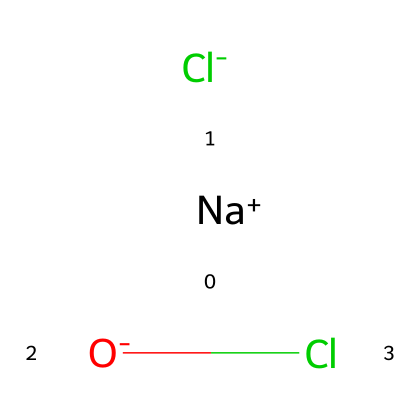What is the chemical name of this compound? The SMILES representation shows the presence of sodium (Na+), chloride (Cl-), and hypochlorite (O-) ions, which collectively represent sodium hypochlorite, commonly known as bleach.
Answer: sodium hypochlorite How many chlorine atoms are present in this chemical? Analyzing the SMILES structure, there are two chlorine representations (one from Cl- and one from Cl in O-Cl), indicating a total of two chlorine atoms.
Answer: two What does the sodium ion contribute to the structure? The sodium ion (Na+) is a cation that balances the negative charges from the anions, allowing the compound to be stable and soluble in water, which is crucial for the cleaning action of bleach.
Answer: stability Is this chemical hazardous? Sodium hypochlorite is classified as a hazardous substance; it can cause irritation to skin, eyes, and respiratory system, and is harmful if ingested, which requires safe handling.
Answer: yes What type of bonding is present in this chemical? The structure consists of ionic bonding between the sodium ion and the chloride ions, while covalent bonding is present within the hypochlorite group (O- bonded to Cl).
Answer: ionic and covalent How does sodium hypochlorite act as a bleach? Sodium hypochlorite acts as a bleach through oxidation, where it breaks down colored substances in fabrics into colorless ones, thus effectively removing stains from football jerseys.
Answer: oxidation 